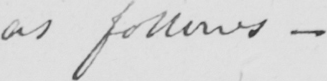What text is written in this handwritten line? as follows  _ 